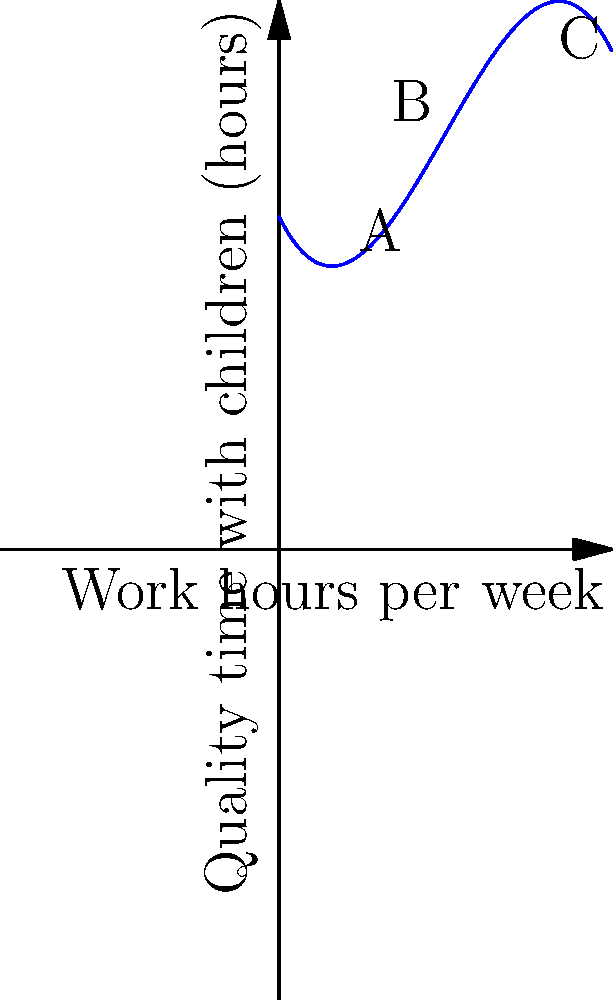The graph represents the relationship between a parent's work hours per week and the quality time spent with children. The function is given by $f(x) = -0.05x^3 + 0.75x^2 - 2x + 10$, where $x$ is the number of work hours per week and $f(x)$ is the quality time spent with children in hours. At which point does the parent spend the most quality time with their children? To find the point where the parent spends the most quality time with their children, we need to identify the maximum point on the graph. Let's analyze the three labeled points:

1. Point A: (2, f(2))
2. Point B: (5, f(5))
3. Point C: (8, f(8))

To determine which point represents the maximum:

1. Calculate f(2):
   $f(2) = -0.05(2)^3 + 0.75(2)^2 - 2(2) + 10 = 8.6$ hours

2. Calculate f(5):
   $f(5) = -0.05(5)^3 + 0.75(5)^2 - 2(5) + 10 = 11.875$ hours

3. Calculate f(8):
   $f(8) = -0.05(8)^3 + 0.75(8)^2 - 2(8) + 10 = 6$ hours

Comparing these values, we can see that f(5) gives the highest value, corresponding to point B.

Therefore, the parent spends the most quality time with their children at point B, which represents 5 work hours per week and approximately 11.875 hours of quality time.
Answer: Point B (5 work hours, 11.875 quality hours) 